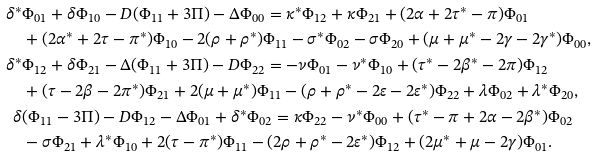Convert formula to latex. <formula><loc_0><loc_0><loc_500><loc_500>\delta ^ { \ast } & \Phi _ { 0 1 } + \delta \Phi _ { 1 0 } - D ( \Phi _ { 1 1 } + 3 \Pi ) - \Delta \Phi _ { 0 0 } = \kappa ^ { \ast } \Phi _ { 1 2 } + \kappa \Phi _ { 2 1 } + ( 2 \alpha + 2 \tau ^ { \ast } - \pi ) \Phi _ { 0 1 } \\ & + ( 2 \alpha ^ { \ast } + 2 \tau - \pi ^ { \ast } ) \Phi _ { 1 0 } - 2 ( \rho + \rho ^ { \ast } ) \Phi _ { 1 1 } - \sigma ^ { \ast } \Phi _ { 0 2 } - \sigma \Phi _ { 2 0 } + ( \mu + \mu ^ { \ast } - 2 \gamma - 2 \gamma ^ { \ast } ) \Phi _ { 0 0 } , \\ \delta ^ { \ast } & \Phi _ { 1 2 } + \delta \Phi _ { 2 1 } - \Delta ( \Phi _ { 1 1 } + 3 \Pi ) - D \Phi _ { 2 2 } = - \nu \Phi _ { 0 1 } - \nu ^ { \ast } \Phi _ { 1 0 } + ( \tau ^ { \ast } - 2 \beta ^ { \ast } - 2 \pi ) \Phi _ { 1 2 } \\ & + ( \tau - 2 \beta - 2 \pi ^ { \ast } ) \Phi _ { 2 1 } + 2 ( \mu + \mu ^ { \ast } ) \Phi _ { 1 1 } - ( \rho + \rho ^ { \ast } - 2 \varepsilon - 2 \varepsilon ^ { \ast } ) \Phi _ { 2 2 } + \lambda \Phi _ { 0 2 } + \lambda ^ { \ast } \Phi _ { 2 0 } , \\ \delta & ( \Phi _ { 1 1 } - 3 \Pi ) - D \Phi _ { 1 2 } - \Delta \Phi _ { 0 1 } + \delta ^ { \ast } \Phi _ { 0 2 } = \kappa \Phi _ { 2 2 } - \nu ^ { \ast } \Phi _ { 0 0 } + ( \tau ^ { \ast } - \pi + 2 \alpha - 2 \beta ^ { \ast } ) \Phi _ { 0 2 } \\ & - \sigma \Phi _ { 2 1 } + \lambda ^ { \ast } \Phi _ { 1 0 } + 2 ( \tau - \pi ^ { \ast } ) \Phi _ { 1 1 } - ( 2 \rho + \rho ^ { \ast } - 2 \varepsilon ^ { \ast } ) \Phi _ { 1 2 } + ( 2 \mu ^ { \ast } + \mu - 2 \gamma ) \Phi _ { 0 1 } . \\</formula> 